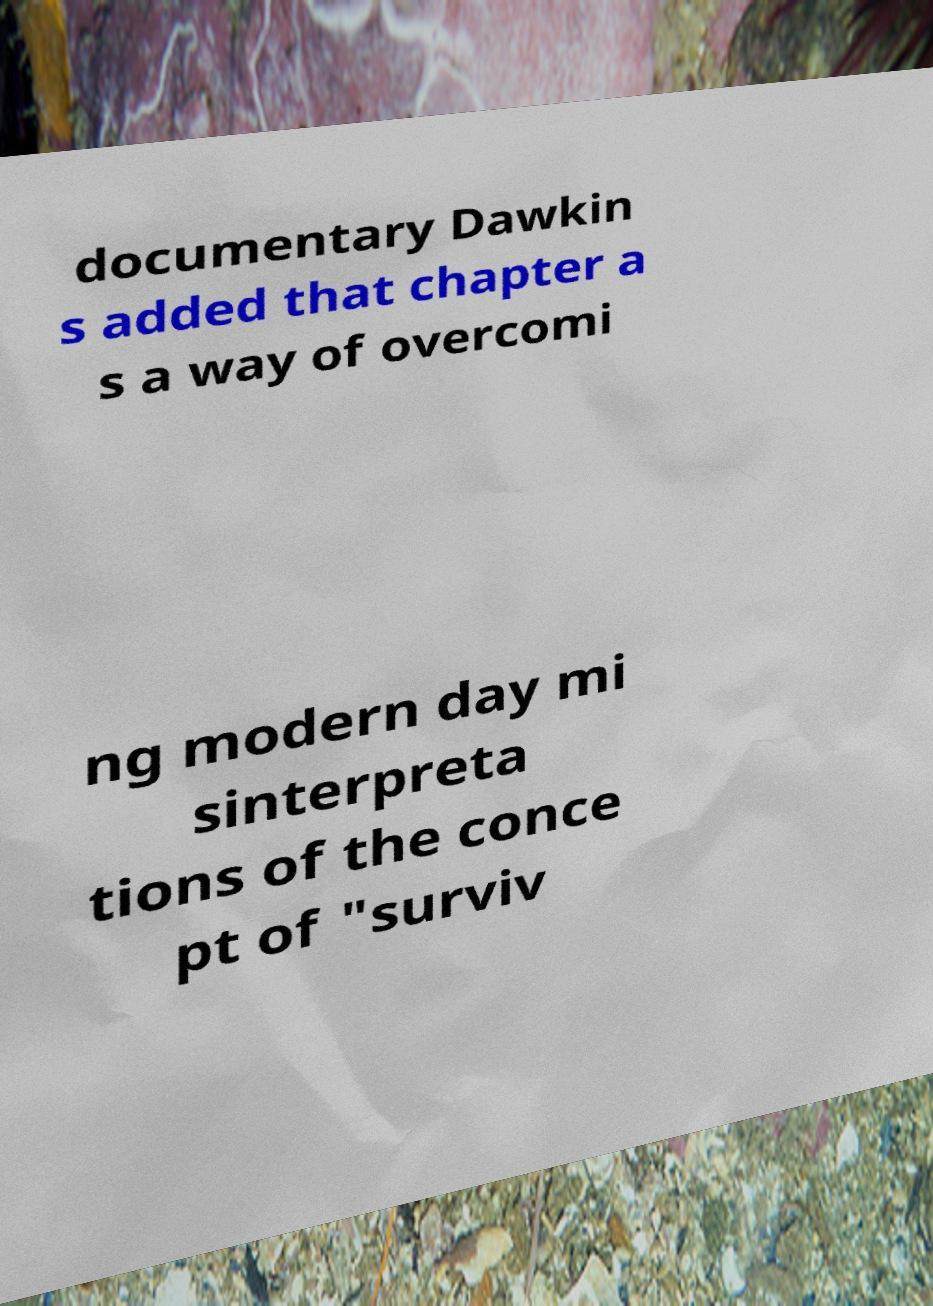What messages or text are displayed in this image? I need them in a readable, typed format. documentary Dawkin s added that chapter a s a way of overcomi ng modern day mi sinterpreta tions of the conce pt of "surviv 